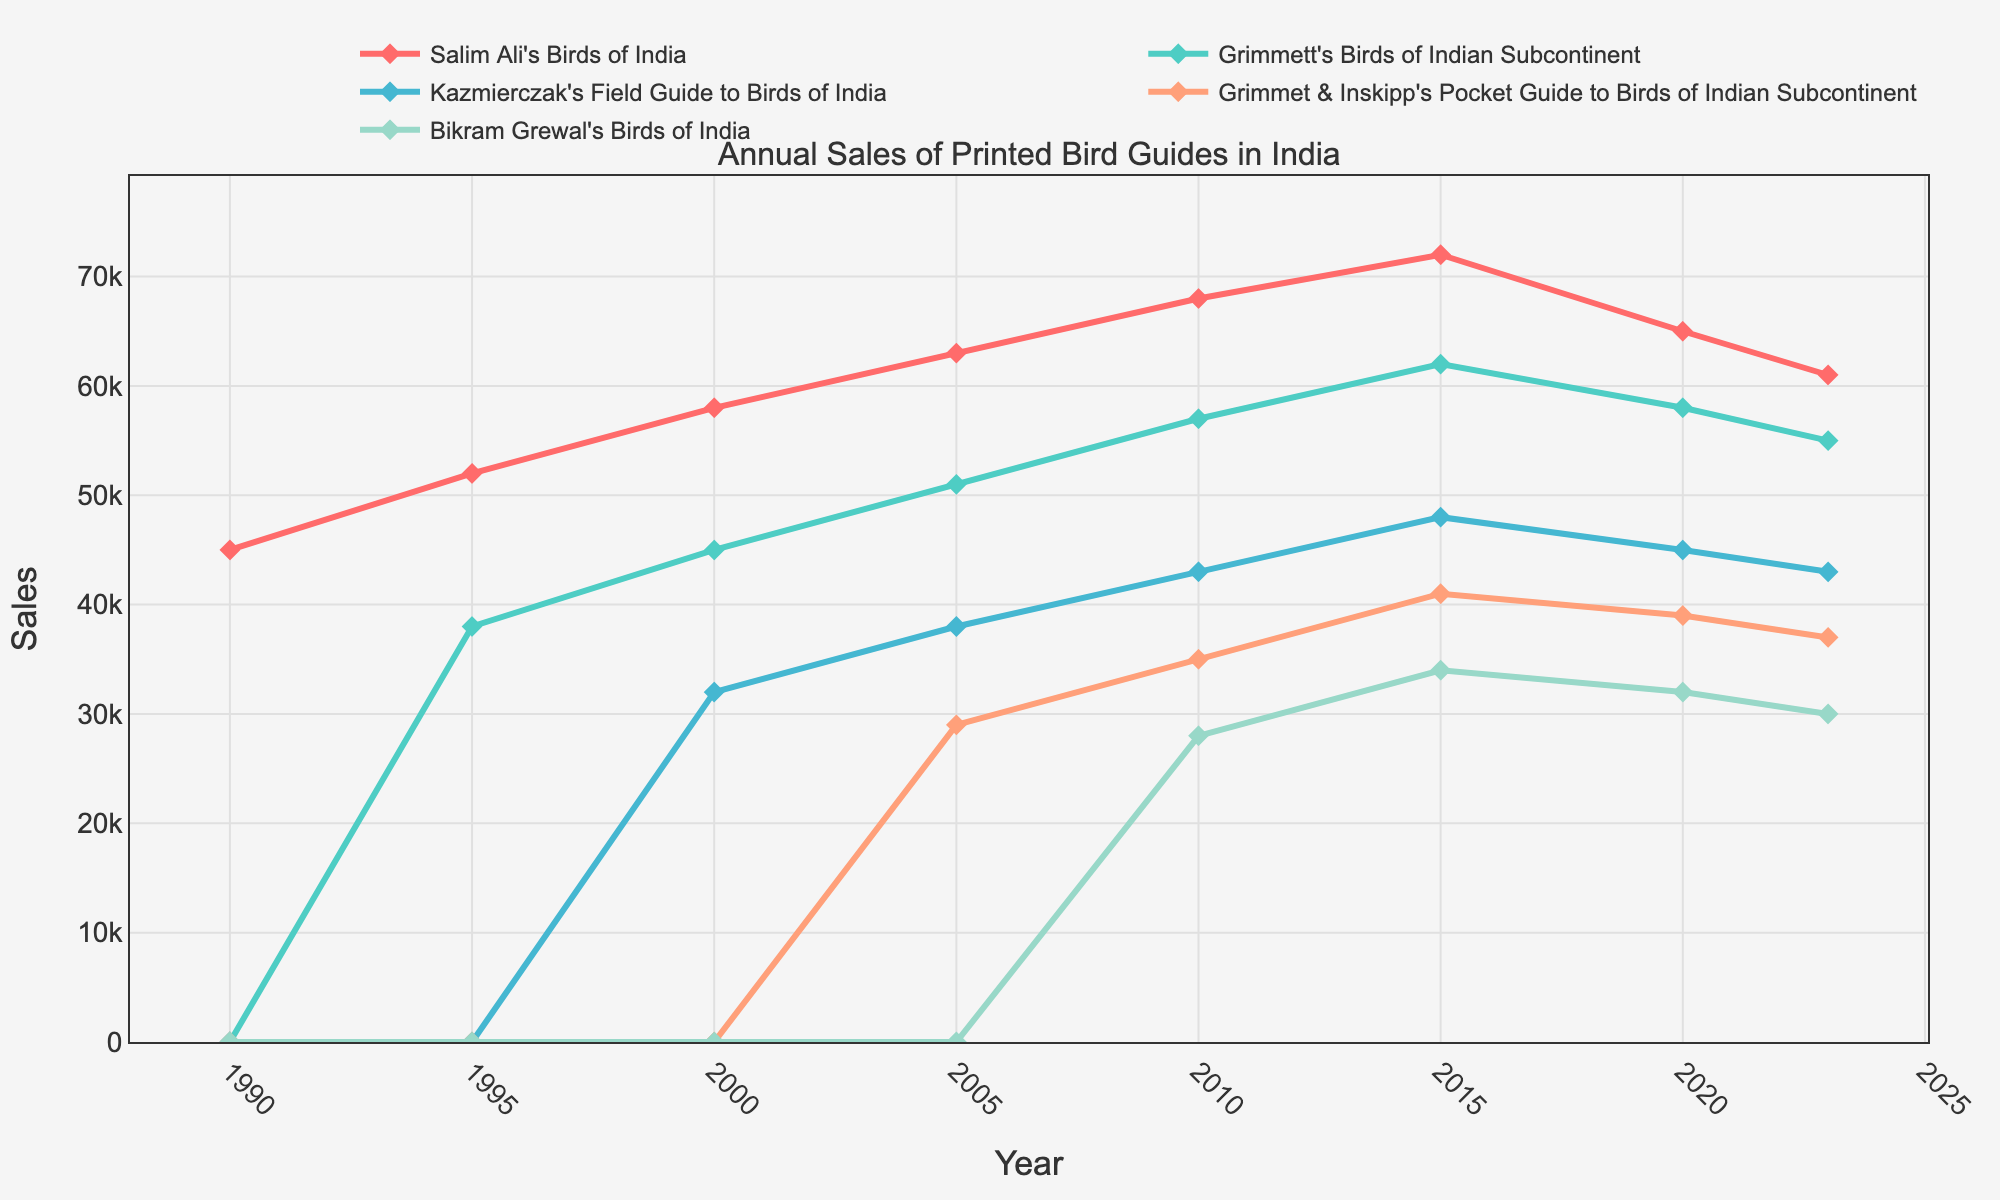What are the sales figures for Salim Ali's Birds of India in 1990 and 2023? The sales figure for the year 1990 can be directly read from the chart where Salim Ali's line starts, and the 2023 figure is the last value of Salim Ali's line.
Answer: 45000 and 61000 Which bird guide had zero sales until 2005 but quite noticeable sales in 2010? From the chart, Grimmet & Inskipp's Pocket Guide sales were zero until they appear on the chart in 2005 onwards.
Answer: Grimmet & Inskipp's Pocket Guide to Birds of Indian Subcontinent How much did the sales of Grimmett's Birds of Indian Subcontinent change from 2000 to 2015? Observe the 2000 and 2015 sales values for Grimmett's guide. Calculate the difference as 62000 (2015) - 45000 (2000).
Answer: 17000 What color represents Bikram Grewal's Birds of India in the chart? The different bird guides are represented by distinct colors, and the one corresponding to Bikram Grewal's is specifically identified by the color used for its line and markers.
Answer: Greenish Between 2005 and 2020, which guide experienced the most significant sales increase? Calculate the sales increases for each guide between 2005 and 2020. Determine the largest value among these differences.
Answer: Salim Ali's Birds of India Which guide experienced a decline in sales from 2015 to 2023, and by how much? Focus on the guides' sales figures for the years 2015 and 2023. Identify the one guide with a sales decrease and compute the difference.
Answer: All guides — Salim Ali's: 11000, Grimmett's: 7000, Kazmierczak's: 5000, Grimmet & Inskipp's: 4000, and Bikram Grewal's: 4000 What was the average sales figure for Kazmierczak's Field Guide to Birds of India over the period it had sales? Add up the sales figures of Kazmierczak's guide over the available years and divide by the number of those years to find the average. (32000 + 38000 + 43000 + 48000 + 45000 + 43000) / 6.
Answer: 41500 In which year did Grimmet & Inskipp's Pocket Guide to Birds of Indian Subcontinent first appear, and what were its sales figures? Look at the first instance of non-zero sales value for Grimmet & Inskipp's guide.
Answer: 2005, 29000 Which guide had the highest sales in the year 2010? Compare the sales figures of all guides for the year 2010 and identify the highest one.
Answer: Salim Ali's Birds of India Between 1995 and 2023, which guide had the most consistent sales trends (least fluctuations)? Examine the consistency of the trends of the lines for each guide from 1995 to 2023 and determine which appears most stable.
Answer: Grimmett's Birds of Indian Subcontinent 